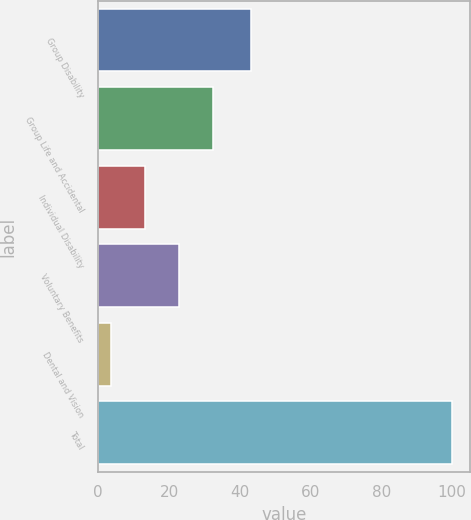Convert chart. <chart><loc_0><loc_0><loc_500><loc_500><bar_chart><fcel>Group Disability<fcel>Group Life and Accidental<fcel>Individual Disability<fcel>Voluntary Benefits<fcel>Dental and Vision<fcel>Total<nl><fcel>43.1<fcel>32.52<fcel>13.24<fcel>22.88<fcel>3.6<fcel>100<nl></chart> 